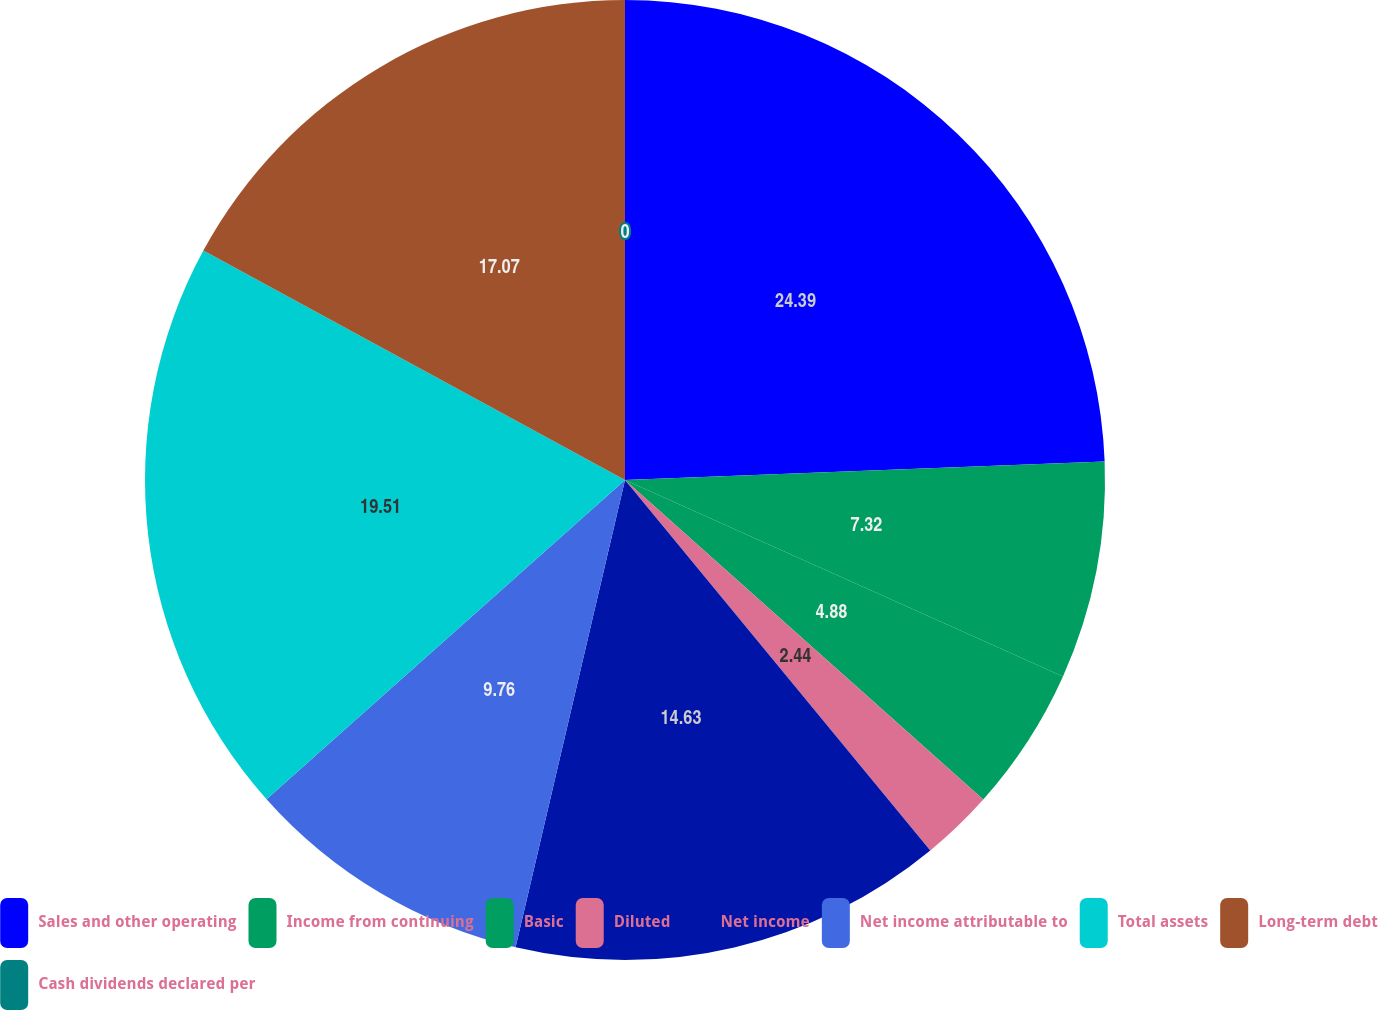Convert chart to OTSL. <chart><loc_0><loc_0><loc_500><loc_500><pie_chart><fcel>Sales and other operating<fcel>Income from continuing<fcel>Basic<fcel>Diluted<fcel>Net income<fcel>Net income attributable to<fcel>Total assets<fcel>Long-term debt<fcel>Cash dividends declared per<nl><fcel>24.39%<fcel>7.32%<fcel>4.88%<fcel>2.44%<fcel>14.63%<fcel>9.76%<fcel>19.51%<fcel>17.07%<fcel>0.0%<nl></chart> 